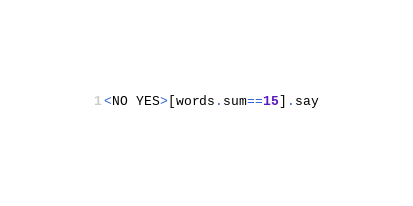Convert code to text. <code><loc_0><loc_0><loc_500><loc_500><_Perl_><NO YES>[words.sum==15].say</code> 